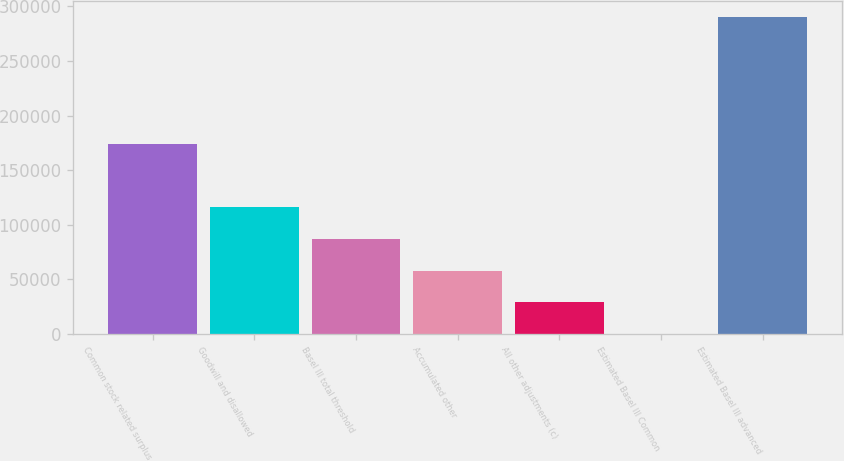Convert chart to OTSL. <chart><loc_0><loc_0><loc_500><loc_500><bar_chart><fcel>Common stock related surplus<fcel>Goodwill and disallowed<fcel>Basel III total threshold<fcel>Accumulated other<fcel>All other adjustments (c)<fcel>Estimated Basel III Common<fcel>Estimated Basel III advanced<nl><fcel>174052<fcel>116038<fcel>87030.6<fcel>58023.5<fcel>29016.5<fcel>9.4<fcel>290080<nl></chart> 